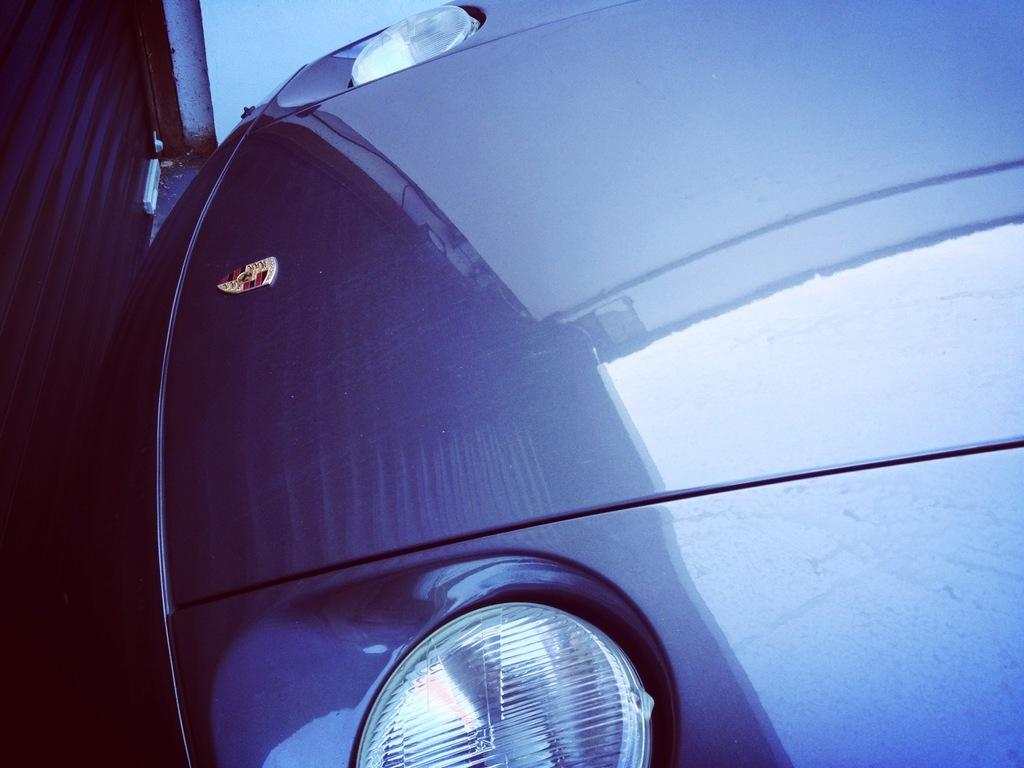What is located on the ground in the image? There is a vehicle on the ground in the image. What object is present that can be opened and closed? There is a shutter in the image. What type of structure can be seen in the image? There is a wall in the image. What type of club is being used to hit the vehicle in the image? There is no club or any indication of a club being used to hit the vehicle in the image. 